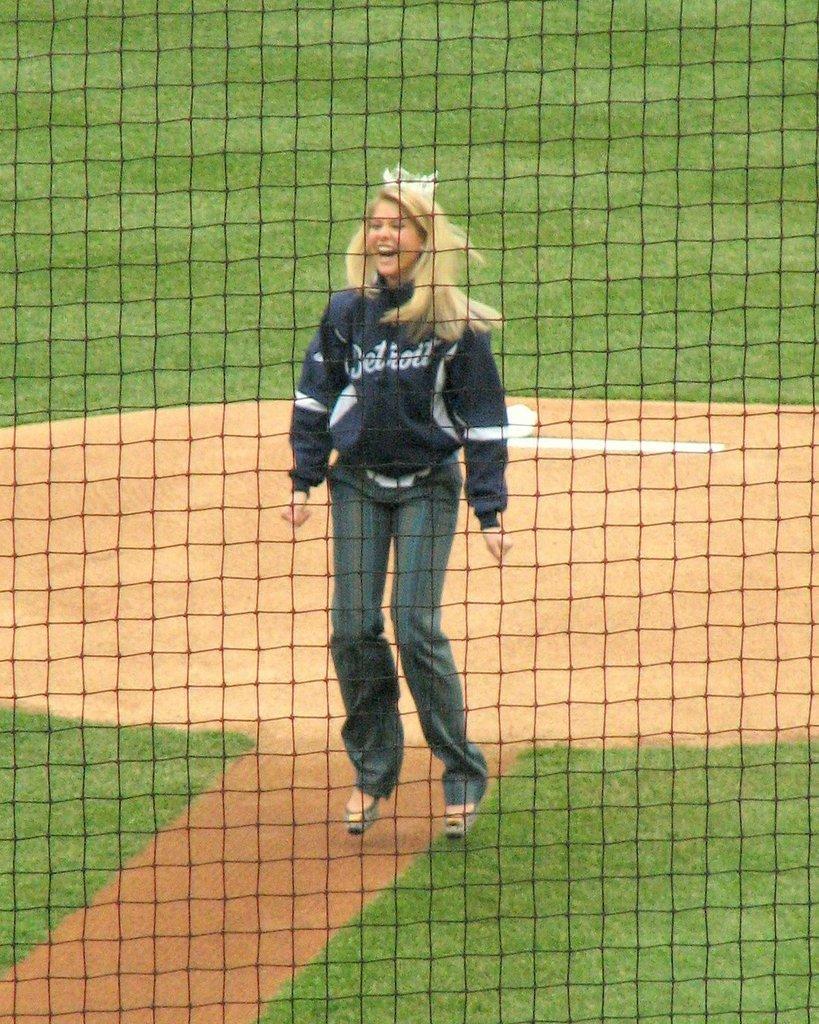How would you summarize this image in a sentence or two? In the picture we can see a net from it, we can see a woman standing and laughing and besides her we can see a grass surface. 